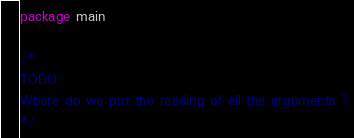Convert code to text. <code><loc_0><loc_0><loc_500><loc_500><_Go_>package main

/*
TODO:
Where do we put the reading of all the arguments ?
*/
</code> 